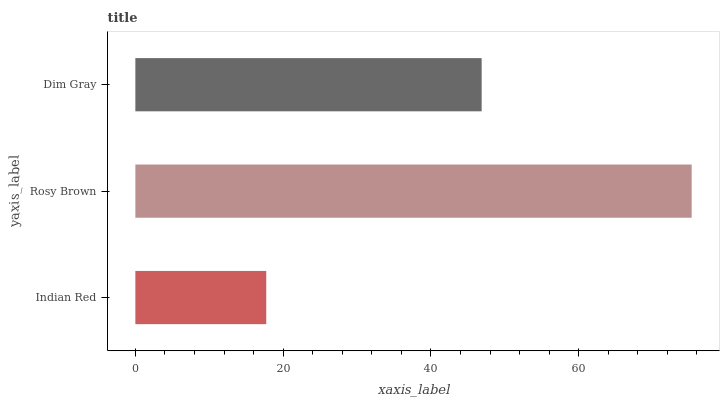Is Indian Red the minimum?
Answer yes or no. Yes. Is Rosy Brown the maximum?
Answer yes or no. Yes. Is Dim Gray the minimum?
Answer yes or no. No. Is Dim Gray the maximum?
Answer yes or no. No. Is Rosy Brown greater than Dim Gray?
Answer yes or no. Yes. Is Dim Gray less than Rosy Brown?
Answer yes or no. Yes. Is Dim Gray greater than Rosy Brown?
Answer yes or no. No. Is Rosy Brown less than Dim Gray?
Answer yes or no. No. Is Dim Gray the high median?
Answer yes or no. Yes. Is Dim Gray the low median?
Answer yes or no. Yes. Is Rosy Brown the high median?
Answer yes or no. No. Is Indian Red the low median?
Answer yes or no. No. 